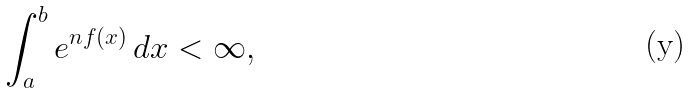<formula> <loc_0><loc_0><loc_500><loc_500>\int _ { a } ^ { b } e ^ { n f ( x ) } \, d x < \infty ,</formula> 